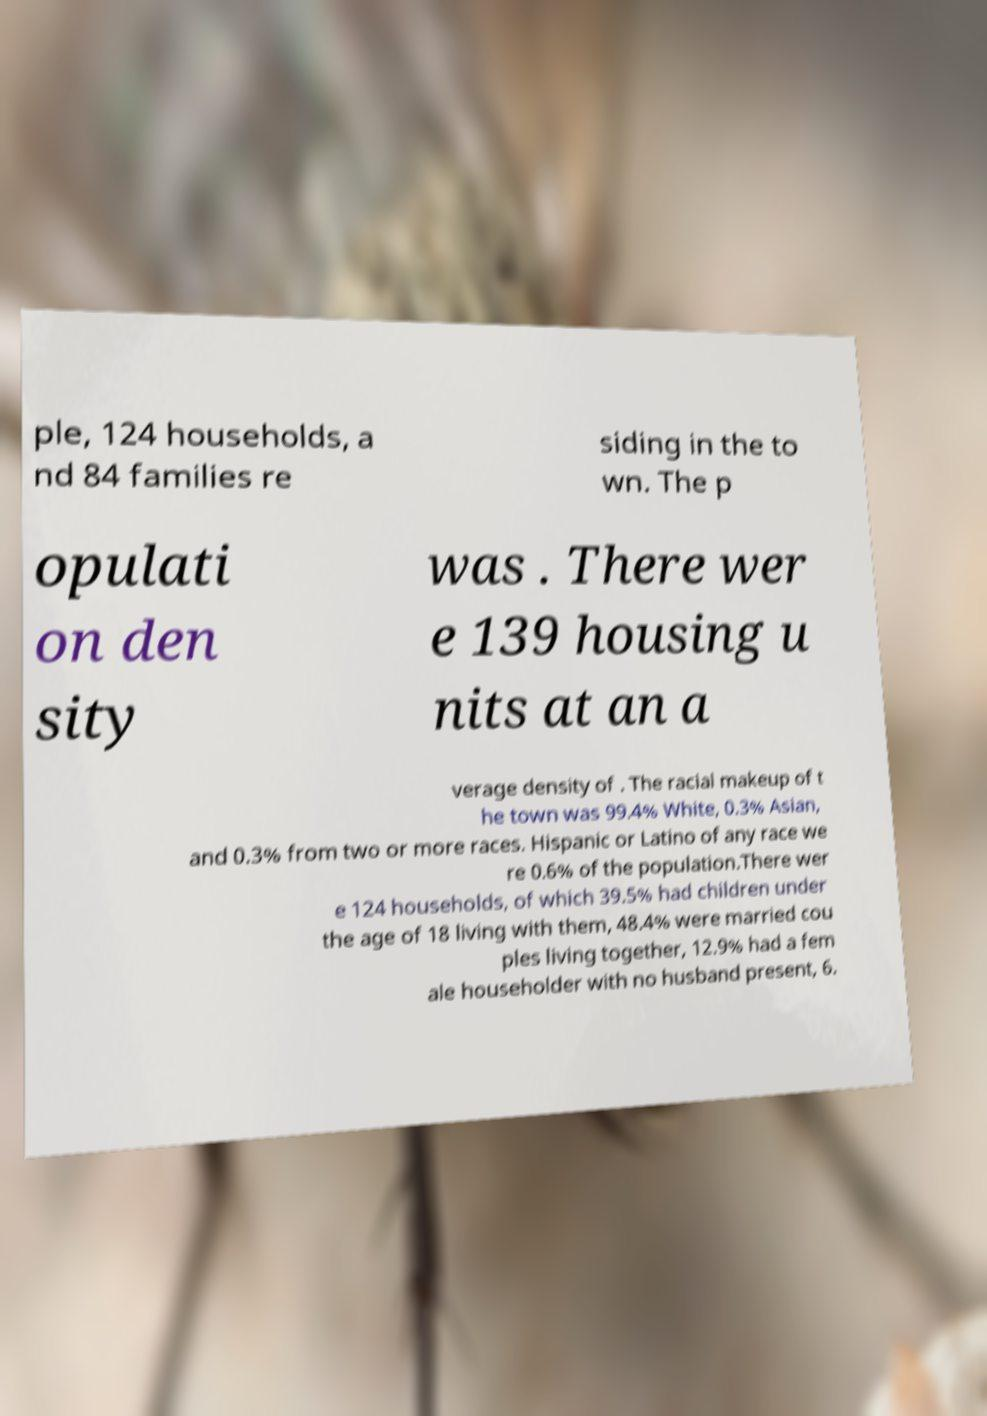Could you extract and type out the text from this image? ple, 124 households, a nd 84 families re siding in the to wn. The p opulati on den sity was . There wer e 139 housing u nits at an a verage density of . The racial makeup of t he town was 99.4% White, 0.3% Asian, and 0.3% from two or more races. Hispanic or Latino of any race we re 0.6% of the population.There wer e 124 households, of which 39.5% had children under the age of 18 living with them, 48.4% were married cou ples living together, 12.9% had a fem ale householder with no husband present, 6. 